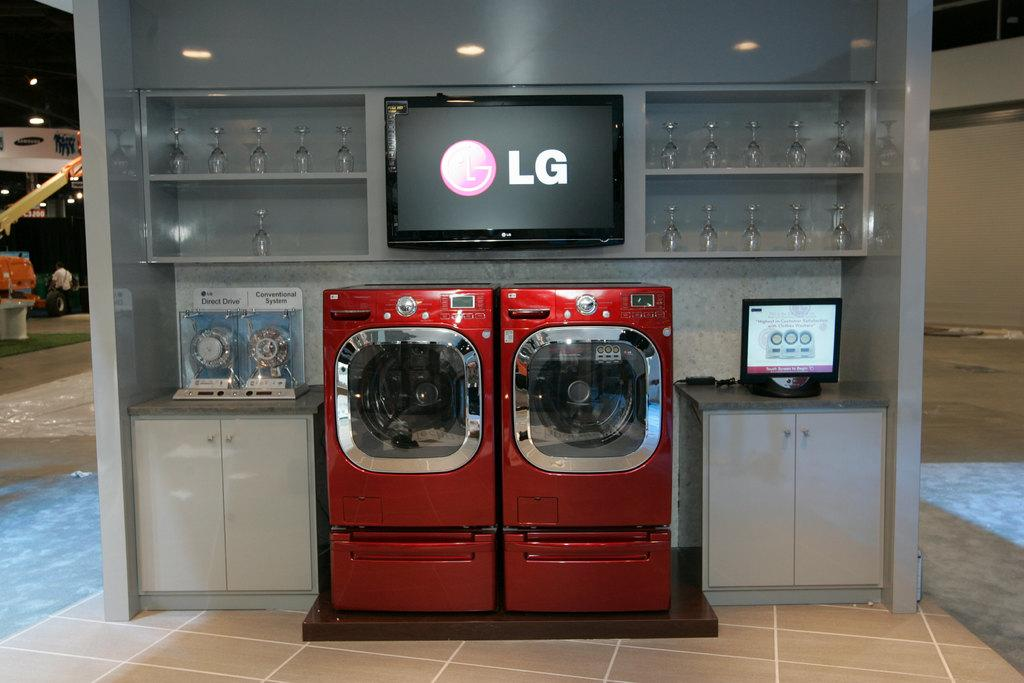<image>
Share a concise interpretation of the image provided. A pair of red washer and dryer under a screen reading LG. 